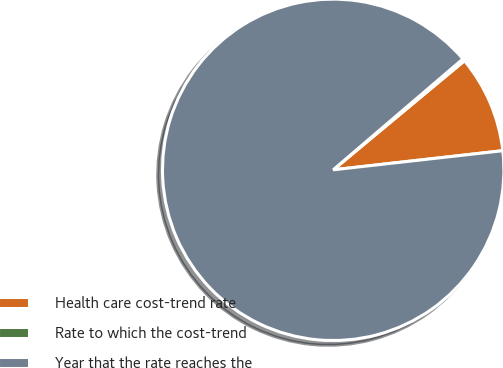<chart> <loc_0><loc_0><loc_500><loc_500><pie_chart><fcel>Health care cost-trend rate<fcel>Rate to which the cost-trend<fcel>Year that the rate reaches the<nl><fcel>9.25%<fcel>0.22%<fcel>90.52%<nl></chart> 